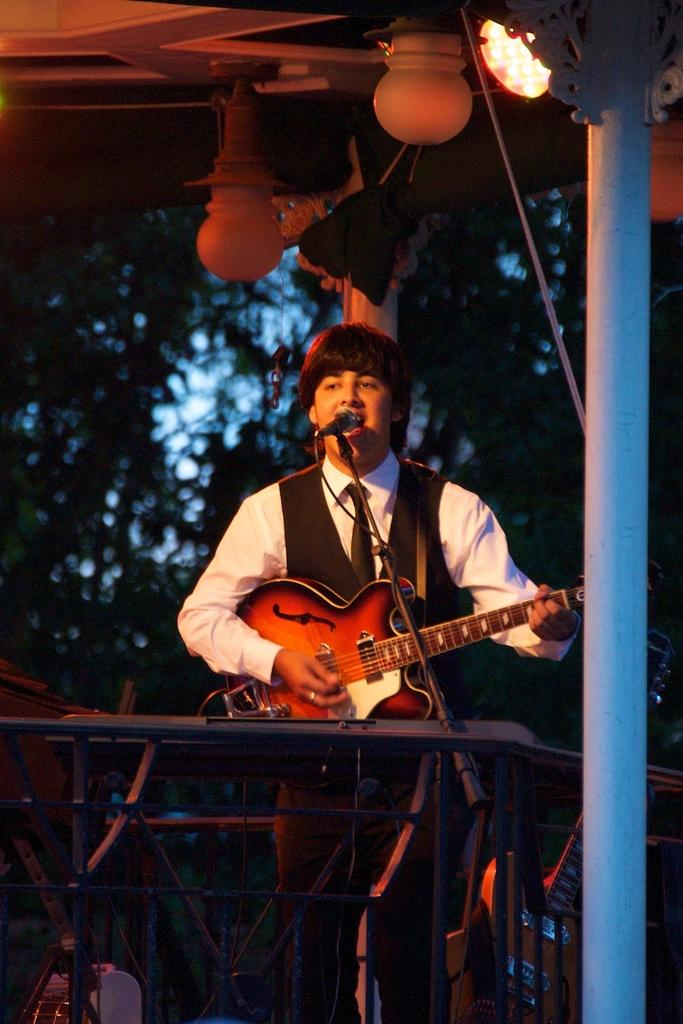What is the man in the image doing? The man is playing the guitar in the image. What object is present that is typically used for amplifying sound? There is a microphone in the image. What type of light can be seen in the image? There is a light in the image. What color is the man's shirt in the image? The man is wearing a white shirt in the image. What type of outerwear is the man wearing in the image? The man is wearing a black jacket in the image. What type of coat is the man wearing in the image? The man is not wearing a coat in the image; he is wearing a black jacket. What type of leaf can be seen falling in the image? There are no leaves present in the image. 